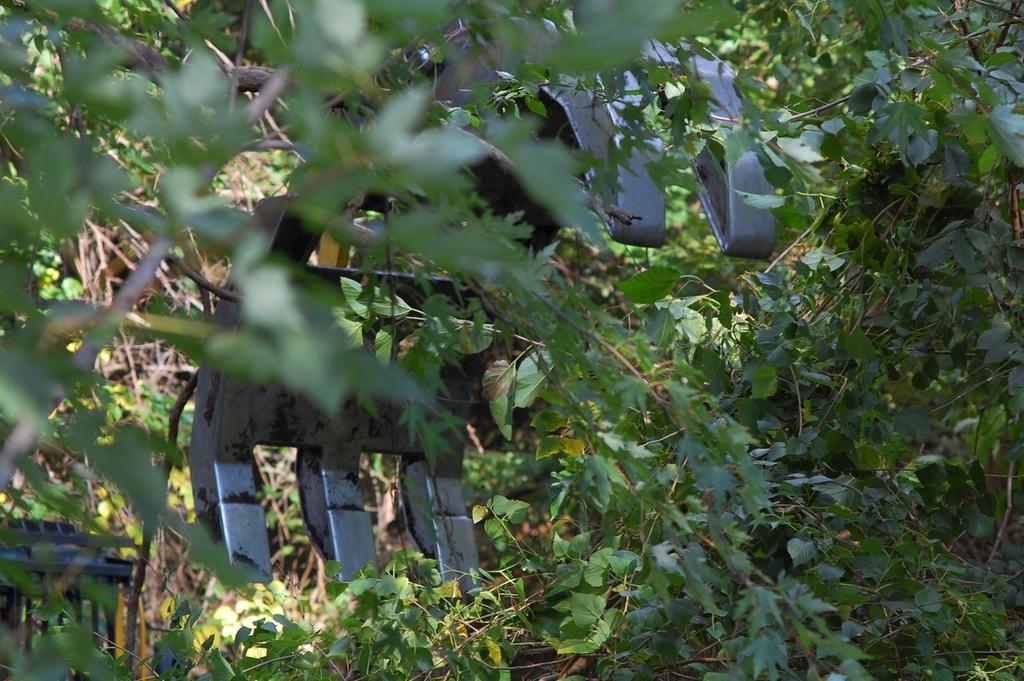Describe this image in one or two sentences. In the picture we can see full of plants in it we can see a metal cutter with six blades. 